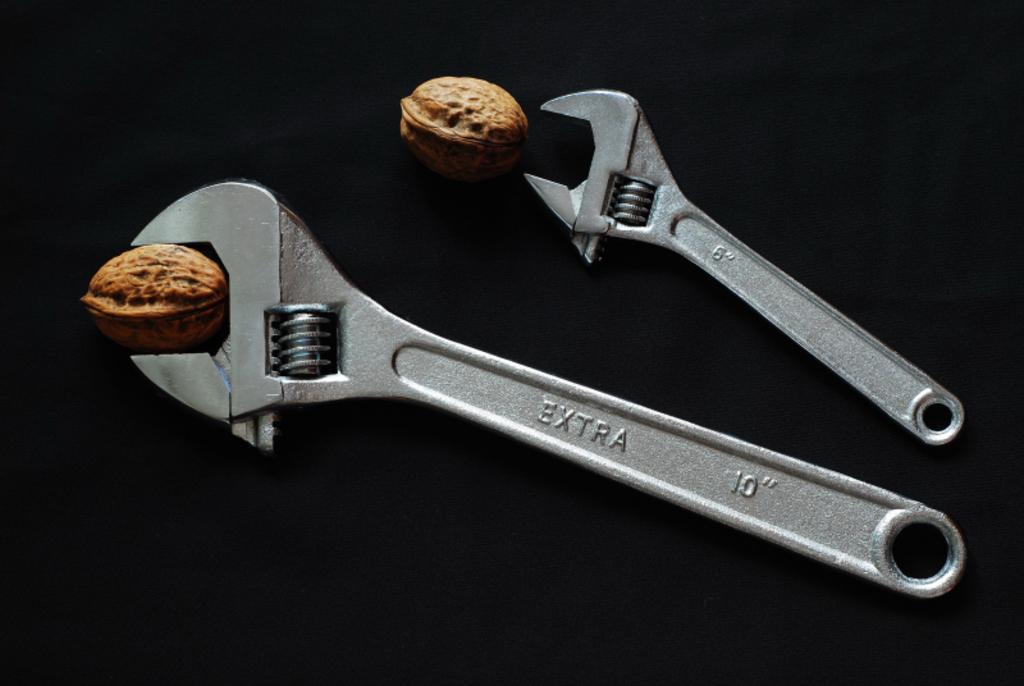Can you describe this image briefly? In this image we can see two wrenches, and two walnuts, and the background is black in color. 